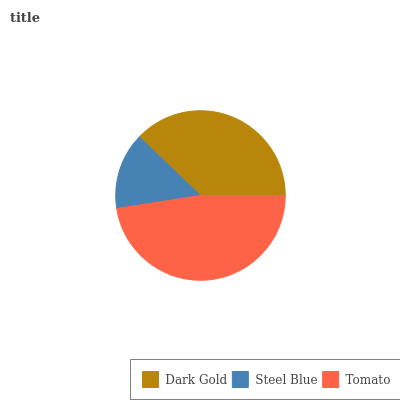Is Steel Blue the minimum?
Answer yes or no. Yes. Is Tomato the maximum?
Answer yes or no. Yes. Is Tomato the minimum?
Answer yes or no. No. Is Steel Blue the maximum?
Answer yes or no. No. Is Tomato greater than Steel Blue?
Answer yes or no. Yes. Is Steel Blue less than Tomato?
Answer yes or no. Yes. Is Steel Blue greater than Tomato?
Answer yes or no. No. Is Tomato less than Steel Blue?
Answer yes or no. No. Is Dark Gold the high median?
Answer yes or no. Yes. Is Dark Gold the low median?
Answer yes or no. Yes. Is Steel Blue the high median?
Answer yes or no. No. Is Steel Blue the low median?
Answer yes or no. No. 